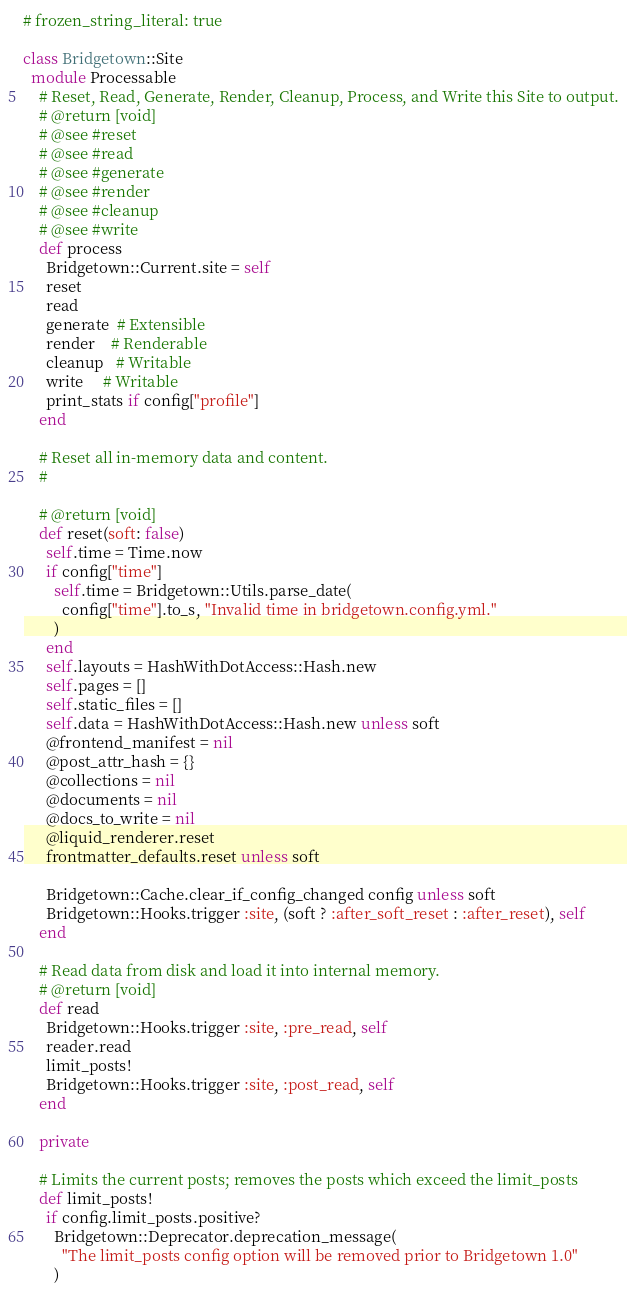<code> <loc_0><loc_0><loc_500><loc_500><_Ruby_># frozen_string_literal: true

class Bridgetown::Site
  module Processable
    # Reset, Read, Generate, Render, Cleanup, Process, and Write this Site to output.
    # @return [void]
    # @see #reset
    # @see #read
    # @see #generate
    # @see #render
    # @see #cleanup
    # @see #write
    def process
      Bridgetown::Current.site = self
      reset
      read
      generate  # Extensible
      render    # Renderable
      cleanup   # Writable
      write     # Writable
      print_stats if config["profile"]
    end

    # Reset all in-memory data and content.
    #

    # @return [void]
    def reset(soft: false)
      self.time = Time.now
      if config["time"]
        self.time = Bridgetown::Utils.parse_date(
          config["time"].to_s, "Invalid time in bridgetown.config.yml."
        )
      end
      self.layouts = HashWithDotAccess::Hash.new
      self.pages = []
      self.static_files = []
      self.data = HashWithDotAccess::Hash.new unless soft
      @frontend_manifest = nil
      @post_attr_hash = {}
      @collections = nil
      @documents = nil
      @docs_to_write = nil
      @liquid_renderer.reset
      frontmatter_defaults.reset unless soft

      Bridgetown::Cache.clear_if_config_changed config unless soft
      Bridgetown::Hooks.trigger :site, (soft ? :after_soft_reset : :after_reset), self
    end

    # Read data from disk and load it into internal memory.
    # @return [void]
    def read
      Bridgetown::Hooks.trigger :site, :pre_read, self
      reader.read
      limit_posts!
      Bridgetown::Hooks.trigger :site, :post_read, self
    end

    private

    # Limits the current posts; removes the posts which exceed the limit_posts
    def limit_posts!
      if config.limit_posts.positive?
        Bridgetown::Deprecator.deprecation_message(
          "The limit_posts config option will be removed prior to Bridgetown 1.0"
        )</code> 